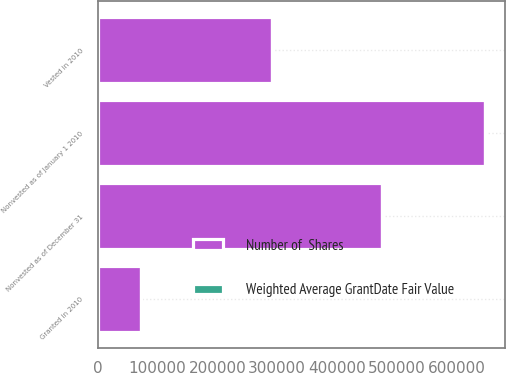Convert chart to OTSL. <chart><loc_0><loc_0><loc_500><loc_500><stacked_bar_chart><ecel><fcel>Nonvested as of January 1 2010<fcel>Nonvested as of December 31<fcel>Granted in 2010<fcel>Vested in 2010<nl><fcel>Number of  Shares<fcel>648293<fcel>475914<fcel>71752<fcel>292152<nl><fcel>Weighted Average GrantDate Fair Value<fcel>50.39<fcel>51.26<fcel>38.43<fcel>38.75<nl></chart> 